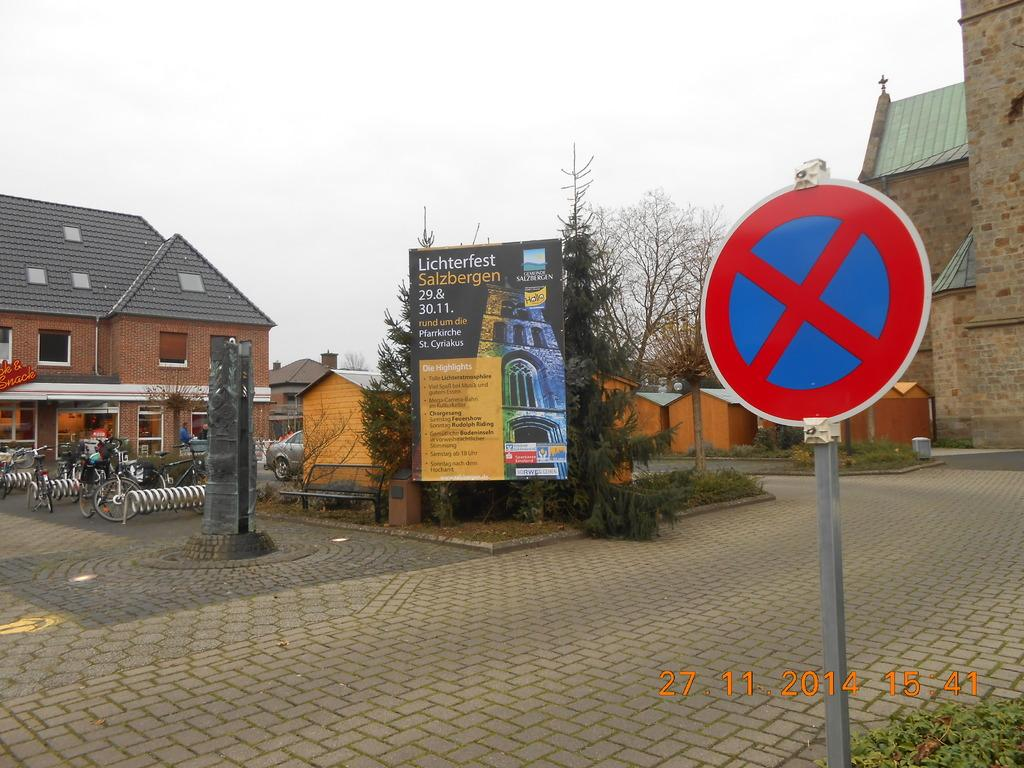<image>
Render a clear and concise summary of the photo. A sign advertises Lichterfest Salzbergen amidst a town square. 